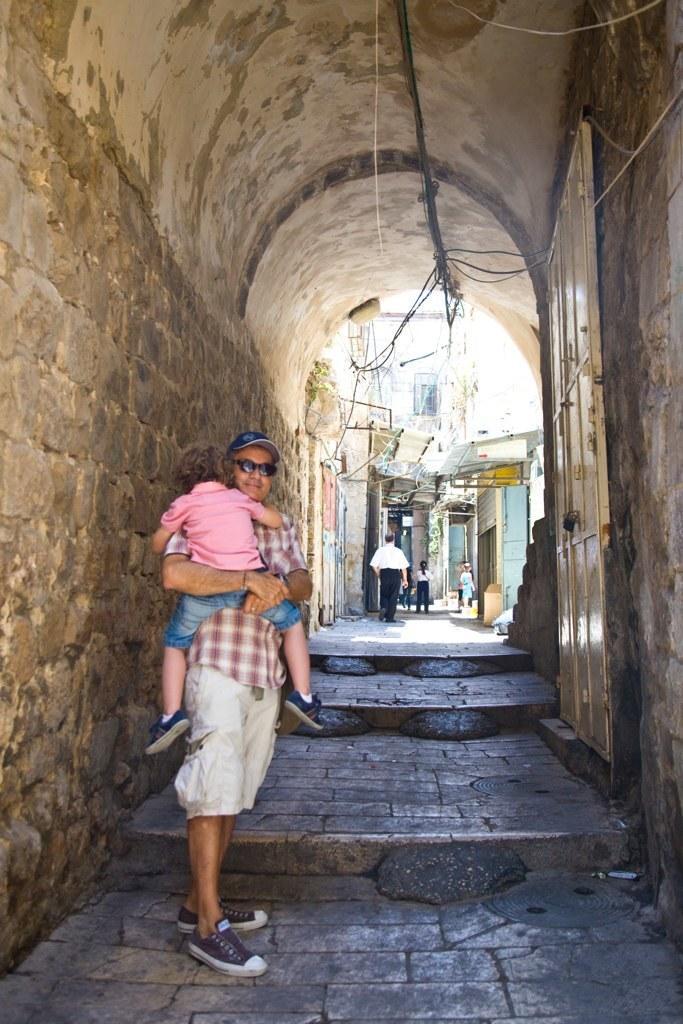In one or two sentences, can you explain what this image depicts? In this image I can see two people with different color dresses and one person wearing the cap. On both sides of these people I can see the wall and to the right I can see the metal door. In the background I can see few more people and the buildings. 